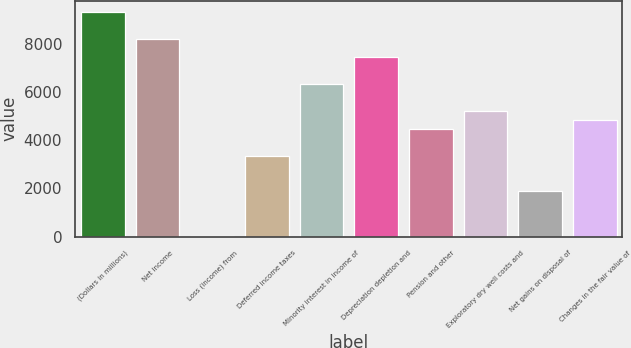Convert chart. <chart><loc_0><loc_0><loc_500><loc_500><bar_chart><fcel>(Dollars in millions)<fcel>Net income<fcel>Loss (income) from<fcel>Deferred income taxes<fcel>Minority interest in income of<fcel>Depreciation depletion and<fcel>Pension and other<fcel>Exploratory dry well costs and<fcel>Net gains on disposal of<fcel>Changes in the fair value of<nl><fcel>9319<fcel>8201.2<fcel>4<fcel>3357.4<fcel>6338.2<fcel>7456<fcel>4475.2<fcel>5220.4<fcel>1867<fcel>4847.8<nl></chart> 